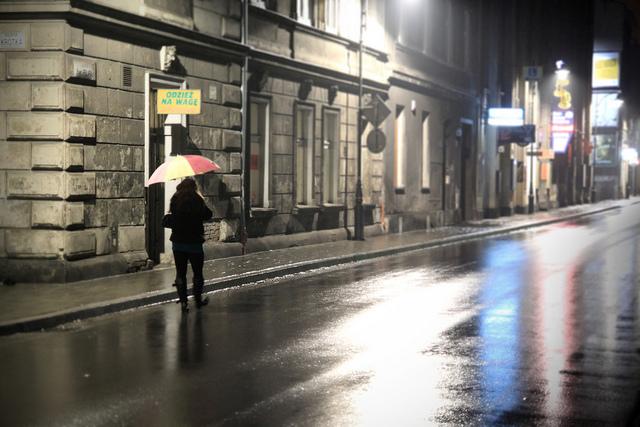Why are the street wet?
Short answer required. Raining. How many people are in the photo?
Give a very brief answer. 1. When will the store open?
Answer briefly. Morning. Why is there a reflection on the road?
Be succinct. Yes. Is the man running or walking?
Give a very brief answer. Walking. 